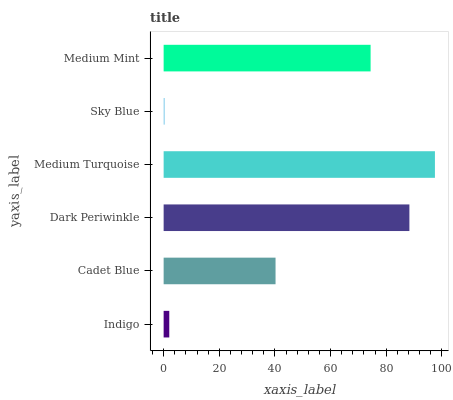Is Sky Blue the minimum?
Answer yes or no. Yes. Is Medium Turquoise the maximum?
Answer yes or no. Yes. Is Cadet Blue the minimum?
Answer yes or no. No. Is Cadet Blue the maximum?
Answer yes or no. No. Is Cadet Blue greater than Indigo?
Answer yes or no. Yes. Is Indigo less than Cadet Blue?
Answer yes or no. Yes. Is Indigo greater than Cadet Blue?
Answer yes or no. No. Is Cadet Blue less than Indigo?
Answer yes or no. No. Is Medium Mint the high median?
Answer yes or no. Yes. Is Cadet Blue the low median?
Answer yes or no. Yes. Is Indigo the high median?
Answer yes or no. No. Is Sky Blue the low median?
Answer yes or no. No. 